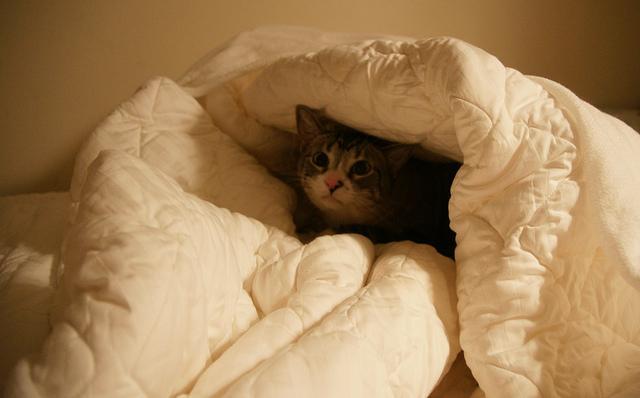How many people are walking in the snow?
Give a very brief answer. 0. 